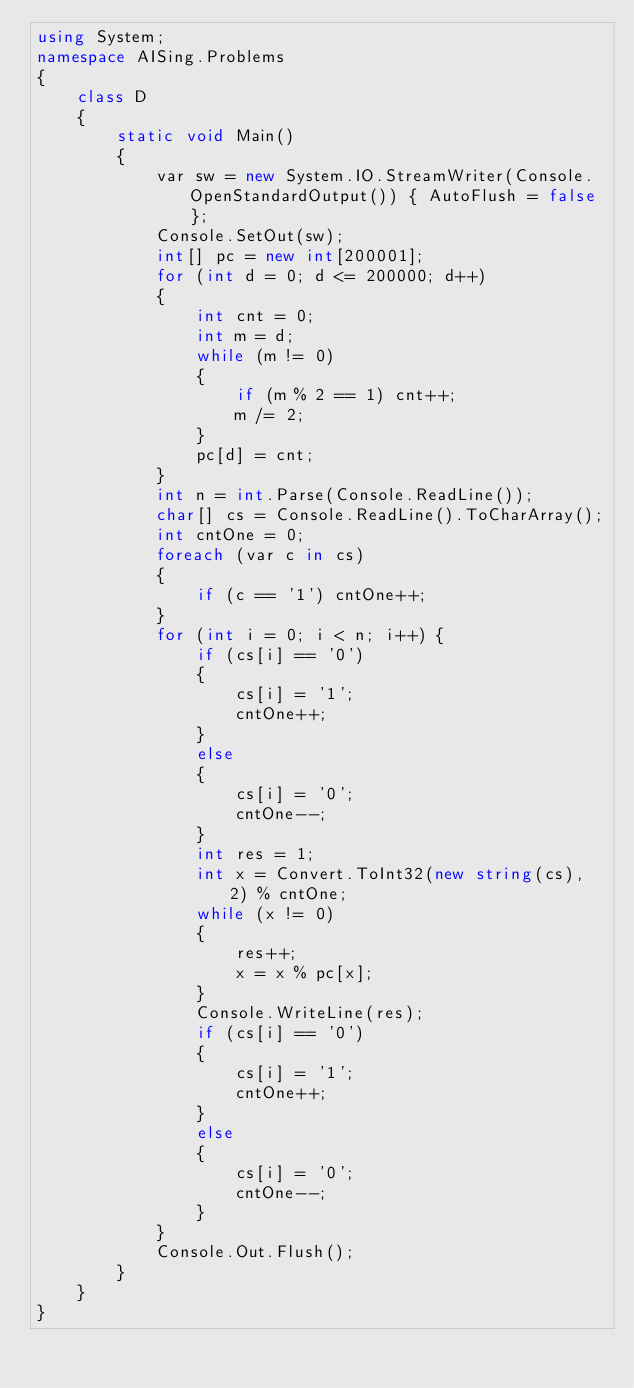Convert code to text. <code><loc_0><loc_0><loc_500><loc_500><_C#_>using System;
namespace AISing.Problems
{
    class D
    {
        static void Main()
        {
            var sw = new System.IO.StreamWriter(Console.OpenStandardOutput()) { AutoFlush = false };
            Console.SetOut(sw);
            int[] pc = new int[200001];
            for (int d = 0; d <= 200000; d++)
            {
                int cnt = 0;
                int m = d;
                while (m != 0)
                {
                    if (m % 2 == 1) cnt++;
                    m /= 2;
                }
                pc[d] = cnt;
            }
            int n = int.Parse(Console.ReadLine());
            char[] cs = Console.ReadLine().ToCharArray();
            int cntOne = 0;
            foreach (var c in cs)
            {
                if (c == '1') cntOne++;
            }
            for (int i = 0; i < n; i++) {
                if (cs[i] == '0')
                {
                    cs[i] = '1';
                    cntOne++;
                }
                else
                {
                    cs[i] = '0';
                    cntOne--;
                }
                int res = 1;
                int x = Convert.ToInt32(new string(cs), 2) % cntOne;
                while (x != 0)
                {
                    res++;
                    x = x % pc[x];
                }
                Console.WriteLine(res);
                if (cs[i] == '0')
                {
                    cs[i] = '1';
                    cntOne++;
                }
                else
                {
                    cs[i] = '0';
                    cntOne--;
                }
            }
            Console.Out.Flush();
        }
    }
}
</code> 